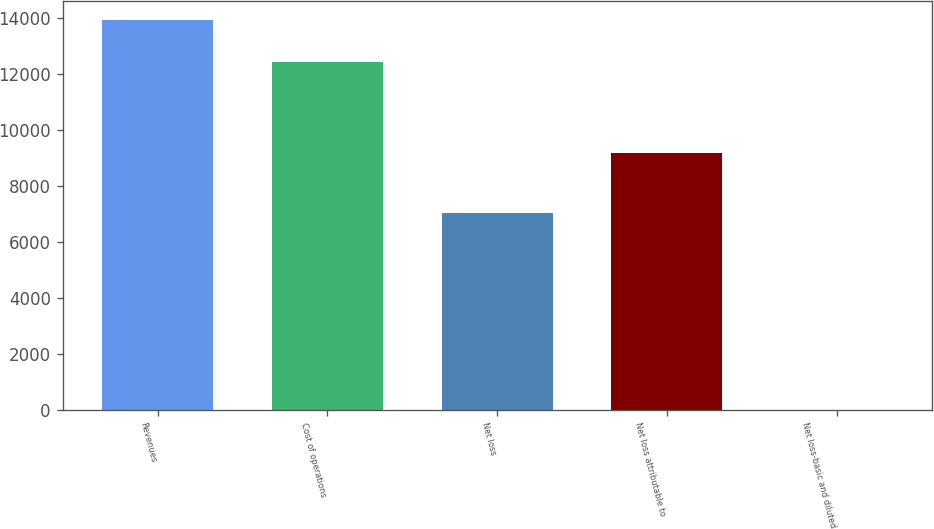Convert chart. <chart><loc_0><loc_0><loc_500><loc_500><bar_chart><fcel>Revenues<fcel>Cost of operations<fcel>Net loss<fcel>Net loss attributable to<fcel>Net loss-basic and diluted<nl><fcel>13929<fcel>12428<fcel>7036<fcel>9183<fcel>1.49<nl></chart> 